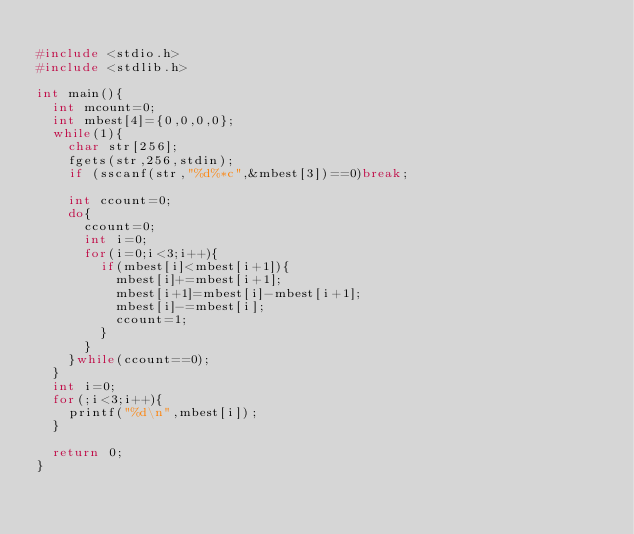Convert code to text. <code><loc_0><loc_0><loc_500><loc_500><_C_>
#include <stdio.h>
#include <stdlib.h>

int main(){
	int mcount=0;
	int mbest[4]={0,0,0,0};
	while(1){
		char str[256];
		fgets(str,256,stdin);
		if (sscanf(str,"%d%*c",&mbest[3])==0)break;

		int ccount=0;
		do{
			ccount=0;
			int i=0;
			for(i=0;i<3;i++){
				if(mbest[i]<mbest[i+1]){
					mbest[i]+=mbest[i+1];
					mbest[i+1]=mbest[i]-mbest[i+1];
					mbest[i]-=mbest[i];
					ccount=1;
				}
			}
		}while(ccount==0);
	}
	int i=0;
	for(;i<3;i++){
		printf("%d\n",mbest[i]);
	}
	
	return 0;
}</code> 